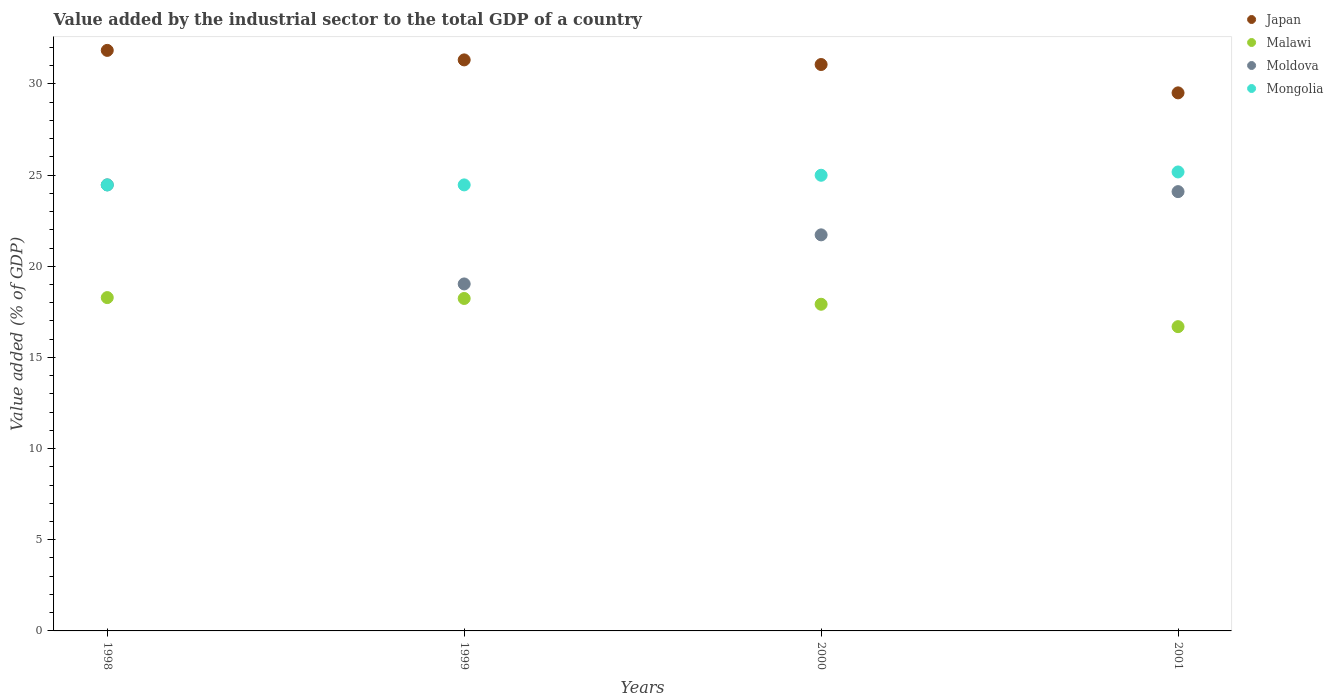Is the number of dotlines equal to the number of legend labels?
Give a very brief answer. Yes. What is the value added by the industrial sector to the total GDP in Moldova in 1998?
Your response must be concise. 24.46. Across all years, what is the maximum value added by the industrial sector to the total GDP in Mongolia?
Your answer should be very brief. 25.17. Across all years, what is the minimum value added by the industrial sector to the total GDP in Mongolia?
Offer a very short reply. 24.46. In which year was the value added by the industrial sector to the total GDP in Japan minimum?
Keep it short and to the point. 2001. What is the total value added by the industrial sector to the total GDP in Moldova in the graph?
Offer a terse response. 89.31. What is the difference between the value added by the industrial sector to the total GDP in Moldova in 2000 and that in 2001?
Offer a terse response. -2.37. What is the difference between the value added by the industrial sector to the total GDP in Malawi in 2000 and the value added by the industrial sector to the total GDP in Mongolia in 2001?
Make the answer very short. -7.26. What is the average value added by the industrial sector to the total GDP in Mongolia per year?
Keep it short and to the point. 24.77. In the year 2000, what is the difference between the value added by the industrial sector to the total GDP in Moldova and value added by the industrial sector to the total GDP in Mongolia?
Your response must be concise. -3.27. In how many years, is the value added by the industrial sector to the total GDP in Mongolia greater than 23 %?
Provide a succinct answer. 4. What is the ratio of the value added by the industrial sector to the total GDP in Malawi in 1998 to that in 2000?
Offer a terse response. 1.02. Is the value added by the industrial sector to the total GDP in Japan in 1998 less than that in 2001?
Keep it short and to the point. No. Is the difference between the value added by the industrial sector to the total GDP in Moldova in 2000 and 2001 greater than the difference between the value added by the industrial sector to the total GDP in Mongolia in 2000 and 2001?
Offer a terse response. No. What is the difference between the highest and the second highest value added by the industrial sector to the total GDP in Moldova?
Keep it short and to the point. 0.37. What is the difference between the highest and the lowest value added by the industrial sector to the total GDP in Malawi?
Offer a very short reply. 1.59. In how many years, is the value added by the industrial sector to the total GDP in Mongolia greater than the average value added by the industrial sector to the total GDP in Mongolia taken over all years?
Keep it short and to the point. 2. Does the value added by the industrial sector to the total GDP in Japan monotonically increase over the years?
Make the answer very short. No. Is the value added by the industrial sector to the total GDP in Japan strictly greater than the value added by the industrial sector to the total GDP in Mongolia over the years?
Offer a very short reply. Yes. Is the value added by the industrial sector to the total GDP in Mongolia strictly less than the value added by the industrial sector to the total GDP in Moldova over the years?
Give a very brief answer. No. How many years are there in the graph?
Make the answer very short. 4. What is the difference between two consecutive major ticks on the Y-axis?
Keep it short and to the point. 5. Does the graph contain any zero values?
Provide a short and direct response. No. Does the graph contain grids?
Your response must be concise. No. Where does the legend appear in the graph?
Provide a short and direct response. Top right. How many legend labels are there?
Keep it short and to the point. 4. How are the legend labels stacked?
Make the answer very short. Vertical. What is the title of the graph?
Offer a terse response. Value added by the industrial sector to the total GDP of a country. Does "Macedonia" appear as one of the legend labels in the graph?
Keep it short and to the point. No. What is the label or title of the X-axis?
Give a very brief answer. Years. What is the label or title of the Y-axis?
Offer a terse response. Value added (% of GDP). What is the Value added (% of GDP) of Japan in 1998?
Your answer should be very brief. 31.84. What is the Value added (% of GDP) in Malawi in 1998?
Give a very brief answer. 18.28. What is the Value added (% of GDP) of Moldova in 1998?
Make the answer very short. 24.46. What is the Value added (% of GDP) of Mongolia in 1998?
Provide a short and direct response. 24.46. What is the Value added (% of GDP) in Japan in 1999?
Provide a succinct answer. 31.32. What is the Value added (% of GDP) in Malawi in 1999?
Make the answer very short. 18.23. What is the Value added (% of GDP) of Moldova in 1999?
Keep it short and to the point. 19.03. What is the Value added (% of GDP) in Mongolia in 1999?
Keep it short and to the point. 24.46. What is the Value added (% of GDP) of Japan in 2000?
Give a very brief answer. 31.06. What is the Value added (% of GDP) of Malawi in 2000?
Give a very brief answer. 17.92. What is the Value added (% of GDP) of Moldova in 2000?
Keep it short and to the point. 21.72. What is the Value added (% of GDP) of Mongolia in 2000?
Your answer should be very brief. 24.99. What is the Value added (% of GDP) in Japan in 2001?
Make the answer very short. 29.51. What is the Value added (% of GDP) of Malawi in 2001?
Provide a short and direct response. 16.69. What is the Value added (% of GDP) in Moldova in 2001?
Make the answer very short. 24.09. What is the Value added (% of GDP) of Mongolia in 2001?
Keep it short and to the point. 25.17. Across all years, what is the maximum Value added (% of GDP) in Japan?
Keep it short and to the point. 31.84. Across all years, what is the maximum Value added (% of GDP) of Malawi?
Keep it short and to the point. 18.28. Across all years, what is the maximum Value added (% of GDP) in Moldova?
Keep it short and to the point. 24.46. Across all years, what is the maximum Value added (% of GDP) of Mongolia?
Offer a terse response. 25.17. Across all years, what is the minimum Value added (% of GDP) of Japan?
Provide a succinct answer. 29.51. Across all years, what is the minimum Value added (% of GDP) of Malawi?
Offer a very short reply. 16.69. Across all years, what is the minimum Value added (% of GDP) in Moldova?
Your answer should be very brief. 19.03. Across all years, what is the minimum Value added (% of GDP) of Mongolia?
Ensure brevity in your answer.  24.46. What is the total Value added (% of GDP) in Japan in the graph?
Offer a very short reply. 123.73. What is the total Value added (% of GDP) of Malawi in the graph?
Provide a succinct answer. 71.12. What is the total Value added (% of GDP) of Moldova in the graph?
Your answer should be very brief. 89.31. What is the total Value added (% of GDP) in Mongolia in the graph?
Offer a very short reply. 99.09. What is the difference between the Value added (% of GDP) of Japan in 1998 and that in 1999?
Make the answer very short. 0.52. What is the difference between the Value added (% of GDP) in Malawi in 1998 and that in 1999?
Your response must be concise. 0.05. What is the difference between the Value added (% of GDP) in Moldova in 1998 and that in 1999?
Provide a succinct answer. 5.43. What is the difference between the Value added (% of GDP) of Mongolia in 1998 and that in 1999?
Offer a terse response. -0. What is the difference between the Value added (% of GDP) of Japan in 1998 and that in 2000?
Your answer should be compact. 0.77. What is the difference between the Value added (% of GDP) of Malawi in 1998 and that in 2000?
Offer a terse response. 0.37. What is the difference between the Value added (% of GDP) in Moldova in 1998 and that in 2000?
Keep it short and to the point. 2.74. What is the difference between the Value added (% of GDP) in Mongolia in 1998 and that in 2000?
Give a very brief answer. -0.53. What is the difference between the Value added (% of GDP) of Japan in 1998 and that in 2001?
Ensure brevity in your answer.  2.33. What is the difference between the Value added (% of GDP) in Malawi in 1998 and that in 2001?
Keep it short and to the point. 1.59. What is the difference between the Value added (% of GDP) in Moldova in 1998 and that in 2001?
Ensure brevity in your answer.  0.37. What is the difference between the Value added (% of GDP) of Mongolia in 1998 and that in 2001?
Offer a terse response. -0.71. What is the difference between the Value added (% of GDP) in Japan in 1999 and that in 2000?
Provide a short and direct response. 0.25. What is the difference between the Value added (% of GDP) in Malawi in 1999 and that in 2000?
Your response must be concise. 0.32. What is the difference between the Value added (% of GDP) of Moldova in 1999 and that in 2000?
Your response must be concise. -2.69. What is the difference between the Value added (% of GDP) of Mongolia in 1999 and that in 2000?
Provide a short and direct response. -0.53. What is the difference between the Value added (% of GDP) of Japan in 1999 and that in 2001?
Give a very brief answer. 1.81. What is the difference between the Value added (% of GDP) in Malawi in 1999 and that in 2001?
Provide a short and direct response. 1.55. What is the difference between the Value added (% of GDP) of Moldova in 1999 and that in 2001?
Keep it short and to the point. -5.06. What is the difference between the Value added (% of GDP) in Mongolia in 1999 and that in 2001?
Your answer should be compact. -0.71. What is the difference between the Value added (% of GDP) of Japan in 2000 and that in 2001?
Your answer should be very brief. 1.55. What is the difference between the Value added (% of GDP) of Malawi in 2000 and that in 2001?
Offer a very short reply. 1.23. What is the difference between the Value added (% of GDP) in Moldova in 2000 and that in 2001?
Keep it short and to the point. -2.37. What is the difference between the Value added (% of GDP) of Mongolia in 2000 and that in 2001?
Offer a terse response. -0.18. What is the difference between the Value added (% of GDP) in Japan in 1998 and the Value added (% of GDP) in Malawi in 1999?
Keep it short and to the point. 13.61. What is the difference between the Value added (% of GDP) of Japan in 1998 and the Value added (% of GDP) of Moldova in 1999?
Keep it short and to the point. 12.81. What is the difference between the Value added (% of GDP) of Japan in 1998 and the Value added (% of GDP) of Mongolia in 1999?
Offer a very short reply. 7.38. What is the difference between the Value added (% of GDP) of Malawi in 1998 and the Value added (% of GDP) of Moldova in 1999?
Offer a terse response. -0.75. What is the difference between the Value added (% of GDP) of Malawi in 1998 and the Value added (% of GDP) of Mongolia in 1999?
Your answer should be very brief. -6.18. What is the difference between the Value added (% of GDP) of Moldova in 1998 and the Value added (% of GDP) of Mongolia in 1999?
Give a very brief answer. 0. What is the difference between the Value added (% of GDP) of Japan in 1998 and the Value added (% of GDP) of Malawi in 2000?
Provide a short and direct response. 13.92. What is the difference between the Value added (% of GDP) in Japan in 1998 and the Value added (% of GDP) in Moldova in 2000?
Offer a very short reply. 10.12. What is the difference between the Value added (% of GDP) of Japan in 1998 and the Value added (% of GDP) of Mongolia in 2000?
Offer a terse response. 6.85. What is the difference between the Value added (% of GDP) of Malawi in 1998 and the Value added (% of GDP) of Moldova in 2000?
Provide a succinct answer. -3.44. What is the difference between the Value added (% of GDP) in Malawi in 1998 and the Value added (% of GDP) in Mongolia in 2000?
Offer a terse response. -6.71. What is the difference between the Value added (% of GDP) in Moldova in 1998 and the Value added (% of GDP) in Mongolia in 2000?
Your response must be concise. -0.53. What is the difference between the Value added (% of GDP) of Japan in 1998 and the Value added (% of GDP) of Malawi in 2001?
Provide a succinct answer. 15.15. What is the difference between the Value added (% of GDP) in Japan in 1998 and the Value added (% of GDP) in Moldova in 2001?
Offer a very short reply. 7.75. What is the difference between the Value added (% of GDP) of Japan in 1998 and the Value added (% of GDP) of Mongolia in 2001?
Give a very brief answer. 6.67. What is the difference between the Value added (% of GDP) of Malawi in 1998 and the Value added (% of GDP) of Moldova in 2001?
Give a very brief answer. -5.81. What is the difference between the Value added (% of GDP) in Malawi in 1998 and the Value added (% of GDP) in Mongolia in 2001?
Keep it short and to the point. -6.89. What is the difference between the Value added (% of GDP) of Moldova in 1998 and the Value added (% of GDP) of Mongolia in 2001?
Provide a short and direct response. -0.71. What is the difference between the Value added (% of GDP) of Japan in 1999 and the Value added (% of GDP) of Malawi in 2000?
Your answer should be compact. 13.4. What is the difference between the Value added (% of GDP) of Japan in 1999 and the Value added (% of GDP) of Moldova in 2000?
Provide a succinct answer. 9.6. What is the difference between the Value added (% of GDP) in Japan in 1999 and the Value added (% of GDP) in Mongolia in 2000?
Give a very brief answer. 6.33. What is the difference between the Value added (% of GDP) in Malawi in 1999 and the Value added (% of GDP) in Moldova in 2000?
Offer a terse response. -3.49. What is the difference between the Value added (% of GDP) in Malawi in 1999 and the Value added (% of GDP) in Mongolia in 2000?
Offer a terse response. -6.76. What is the difference between the Value added (% of GDP) of Moldova in 1999 and the Value added (% of GDP) of Mongolia in 2000?
Your response must be concise. -5.96. What is the difference between the Value added (% of GDP) in Japan in 1999 and the Value added (% of GDP) in Malawi in 2001?
Offer a terse response. 14.63. What is the difference between the Value added (% of GDP) in Japan in 1999 and the Value added (% of GDP) in Moldova in 2001?
Give a very brief answer. 7.23. What is the difference between the Value added (% of GDP) in Japan in 1999 and the Value added (% of GDP) in Mongolia in 2001?
Offer a very short reply. 6.15. What is the difference between the Value added (% of GDP) in Malawi in 1999 and the Value added (% of GDP) in Moldova in 2001?
Keep it short and to the point. -5.86. What is the difference between the Value added (% of GDP) of Malawi in 1999 and the Value added (% of GDP) of Mongolia in 2001?
Keep it short and to the point. -6.94. What is the difference between the Value added (% of GDP) in Moldova in 1999 and the Value added (% of GDP) in Mongolia in 2001?
Offer a very short reply. -6.14. What is the difference between the Value added (% of GDP) in Japan in 2000 and the Value added (% of GDP) in Malawi in 2001?
Give a very brief answer. 14.38. What is the difference between the Value added (% of GDP) in Japan in 2000 and the Value added (% of GDP) in Moldova in 2001?
Your response must be concise. 6.97. What is the difference between the Value added (% of GDP) in Japan in 2000 and the Value added (% of GDP) in Mongolia in 2001?
Your answer should be compact. 5.89. What is the difference between the Value added (% of GDP) of Malawi in 2000 and the Value added (% of GDP) of Moldova in 2001?
Offer a terse response. -6.18. What is the difference between the Value added (% of GDP) of Malawi in 2000 and the Value added (% of GDP) of Mongolia in 2001?
Provide a succinct answer. -7.26. What is the difference between the Value added (% of GDP) of Moldova in 2000 and the Value added (% of GDP) of Mongolia in 2001?
Make the answer very short. -3.45. What is the average Value added (% of GDP) of Japan per year?
Provide a short and direct response. 30.93. What is the average Value added (% of GDP) in Malawi per year?
Provide a succinct answer. 17.78. What is the average Value added (% of GDP) of Moldova per year?
Make the answer very short. 22.33. What is the average Value added (% of GDP) of Mongolia per year?
Ensure brevity in your answer.  24.77. In the year 1998, what is the difference between the Value added (% of GDP) in Japan and Value added (% of GDP) in Malawi?
Your answer should be very brief. 13.56. In the year 1998, what is the difference between the Value added (% of GDP) in Japan and Value added (% of GDP) in Moldova?
Give a very brief answer. 7.38. In the year 1998, what is the difference between the Value added (% of GDP) in Japan and Value added (% of GDP) in Mongolia?
Keep it short and to the point. 7.38. In the year 1998, what is the difference between the Value added (% of GDP) in Malawi and Value added (% of GDP) in Moldova?
Provide a succinct answer. -6.18. In the year 1998, what is the difference between the Value added (% of GDP) of Malawi and Value added (% of GDP) of Mongolia?
Provide a short and direct response. -6.18. In the year 1998, what is the difference between the Value added (% of GDP) of Moldova and Value added (% of GDP) of Mongolia?
Offer a terse response. 0. In the year 1999, what is the difference between the Value added (% of GDP) of Japan and Value added (% of GDP) of Malawi?
Make the answer very short. 13.08. In the year 1999, what is the difference between the Value added (% of GDP) of Japan and Value added (% of GDP) of Moldova?
Offer a very short reply. 12.29. In the year 1999, what is the difference between the Value added (% of GDP) in Japan and Value added (% of GDP) in Mongolia?
Offer a very short reply. 6.86. In the year 1999, what is the difference between the Value added (% of GDP) of Malawi and Value added (% of GDP) of Moldova?
Keep it short and to the point. -0.8. In the year 1999, what is the difference between the Value added (% of GDP) of Malawi and Value added (% of GDP) of Mongolia?
Offer a terse response. -6.23. In the year 1999, what is the difference between the Value added (% of GDP) of Moldova and Value added (% of GDP) of Mongolia?
Provide a succinct answer. -5.43. In the year 2000, what is the difference between the Value added (% of GDP) in Japan and Value added (% of GDP) in Malawi?
Your answer should be compact. 13.15. In the year 2000, what is the difference between the Value added (% of GDP) of Japan and Value added (% of GDP) of Moldova?
Give a very brief answer. 9.34. In the year 2000, what is the difference between the Value added (% of GDP) in Japan and Value added (% of GDP) in Mongolia?
Your response must be concise. 6.07. In the year 2000, what is the difference between the Value added (% of GDP) in Malawi and Value added (% of GDP) in Moldova?
Offer a very short reply. -3.81. In the year 2000, what is the difference between the Value added (% of GDP) of Malawi and Value added (% of GDP) of Mongolia?
Your answer should be compact. -7.07. In the year 2000, what is the difference between the Value added (% of GDP) in Moldova and Value added (% of GDP) in Mongolia?
Give a very brief answer. -3.27. In the year 2001, what is the difference between the Value added (% of GDP) in Japan and Value added (% of GDP) in Malawi?
Keep it short and to the point. 12.82. In the year 2001, what is the difference between the Value added (% of GDP) in Japan and Value added (% of GDP) in Moldova?
Provide a short and direct response. 5.42. In the year 2001, what is the difference between the Value added (% of GDP) in Japan and Value added (% of GDP) in Mongolia?
Give a very brief answer. 4.34. In the year 2001, what is the difference between the Value added (% of GDP) in Malawi and Value added (% of GDP) in Moldova?
Offer a terse response. -7.41. In the year 2001, what is the difference between the Value added (% of GDP) of Malawi and Value added (% of GDP) of Mongolia?
Offer a terse response. -8.48. In the year 2001, what is the difference between the Value added (% of GDP) of Moldova and Value added (% of GDP) of Mongolia?
Give a very brief answer. -1.08. What is the ratio of the Value added (% of GDP) of Japan in 1998 to that in 1999?
Make the answer very short. 1.02. What is the ratio of the Value added (% of GDP) of Moldova in 1998 to that in 1999?
Provide a succinct answer. 1.29. What is the ratio of the Value added (% of GDP) of Mongolia in 1998 to that in 1999?
Provide a short and direct response. 1. What is the ratio of the Value added (% of GDP) in Japan in 1998 to that in 2000?
Provide a short and direct response. 1.02. What is the ratio of the Value added (% of GDP) of Malawi in 1998 to that in 2000?
Give a very brief answer. 1.02. What is the ratio of the Value added (% of GDP) of Moldova in 1998 to that in 2000?
Provide a short and direct response. 1.13. What is the ratio of the Value added (% of GDP) of Mongolia in 1998 to that in 2000?
Make the answer very short. 0.98. What is the ratio of the Value added (% of GDP) in Japan in 1998 to that in 2001?
Keep it short and to the point. 1.08. What is the ratio of the Value added (% of GDP) in Malawi in 1998 to that in 2001?
Ensure brevity in your answer.  1.1. What is the ratio of the Value added (% of GDP) in Moldova in 1998 to that in 2001?
Keep it short and to the point. 1.02. What is the ratio of the Value added (% of GDP) in Mongolia in 1998 to that in 2001?
Keep it short and to the point. 0.97. What is the ratio of the Value added (% of GDP) in Japan in 1999 to that in 2000?
Offer a terse response. 1.01. What is the ratio of the Value added (% of GDP) of Malawi in 1999 to that in 2000?
Your answer should be very brief. 1.02. What is the ratio of the Value added (% of GDP) of Moldova in 1999 to that in 2000?
Your response must be concise. 0.88. What is the ratio of the Value added (% of GDP) of Mongolia in 1999 to that in 2000?
Your answer should be compact. 0.98. What is the ratio of the Value added (% of GDP) in Japan in 1999 to that in 2001?
Your response must be concise. 1.06. What is the ratio of the Value added (% of GDP) in Malawi in 1999 to that in 2001?
Ensure brevity in your answer.  1.09. What is the ratio of the Value added (% of GDP) in Moldova in 1999 to that in 2001?
Offer a terse response. 0.79. What is the ratio of the Value added (% of GDP) in Mongolia in 1999 to that in 2001?
Make the answer very short. 0.97. What is the ratio of the Value added (% of GDP) in Japan in 2000 to that in 2001?
Your response must be concise. 1.05. What is the ratio of the Value added (% of GDP) in Malawi in 2000 to that in 2001?
Offer a terse response. 1.07. What is the ratio of the Value added (% of GDP) of Moldova in 2000 to that in 2001?
Your response must be concise. 0.9. What is the difference between the highest and the second highest Value added (% of GDP) of Japan?
Give a very brief answer. 0.52. What is the difference between the highest and the second highest Value added (% of GDP) of Malawi?
Provide a succinct answer. 0.05. What is the difference between the highest and the second highest Value added (% of GDP) of Moldova?
Make the answer very short. 0.37. What is the difference between the highest and the second highest Value added (% of GDP) of Mongolia?
Give a very brief answer. 0.18. What is the difference between the highest and the lowest Value added (% of GDP) of Japan?
Your response must be concise. 2.33. What is the difference between the highest and the lowest Value added (% of GDP) of Malawi?
Offer a very short reply. 1.59. What is the difference between the highest and the lowest Value added (% of GDP) in Moldova?
Offer a very short reply. 5.43. What is the difference between the highest and the lowest Value added (% of GDP) of Mongolia?
Provide a succinct answer. 0.71. 